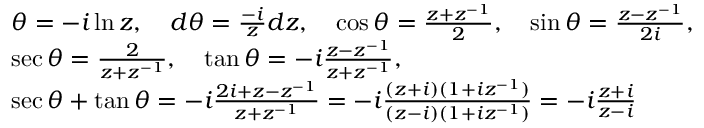<formula> <loc_0><loc_0><loc_500><loc_500>{ \begin{array} { r l } & { \theta = - i \ln z , \quad d \theta = { \frac { - i } { z } } d z , \quad \cos \theta = { \frac { z + z ^ { - 1 } } { 2 } } , \quad \sin \theta = { \frac { z - z ^ { - 1 } } { 2 i } } , \quad } \\ & { \sec \theta = { \frac { 2 } { z + z ^ { - 1 } } } , \quad \tan \theta = - i { \frac { z - z ^ { - 1 } } { z + z ^ { - 1 } } } , \quad } \\ & { \sec \theta + \tan \theta = - i { \frac { 2 i + z - z ^ { - 1 } } { z + z ^ { - 1 } } } = - i { \frac { ( z + i ) ( 1 + i z ^ { - 1 } ) } { ( z - i ) ( 1 + i z ^ { - 1 } ) } } = - i { \frac { z + i } { z - i } } } \end{array} }</formula> 